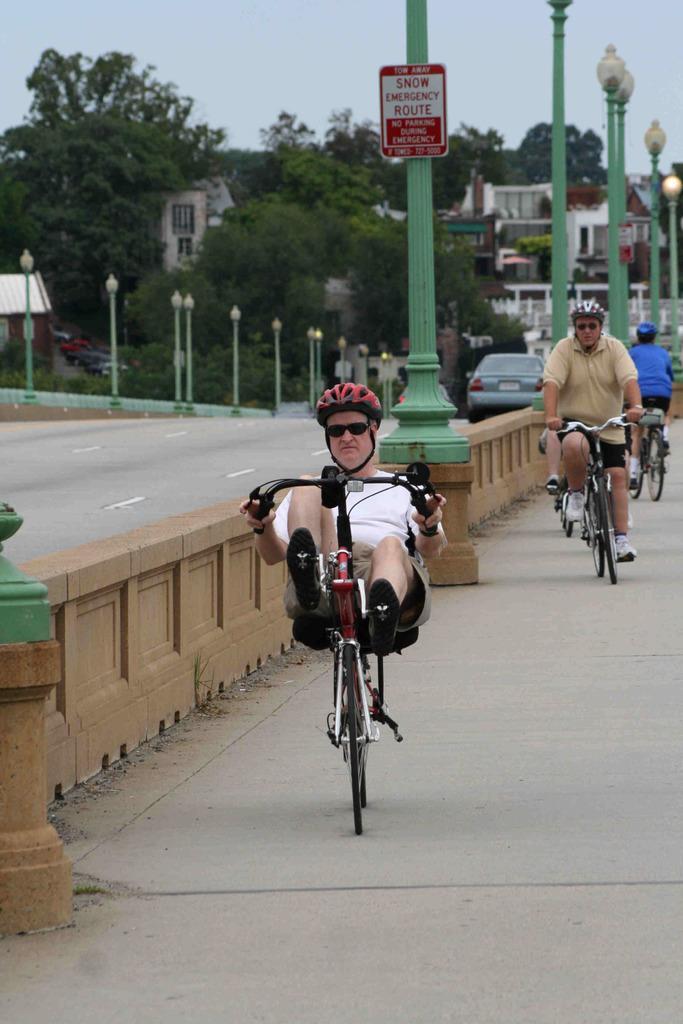Please provide a concise description of this image. In this image i can see few persons riding a bicycles, all of them are wearing helmets. In the background i can see few trees, few building, few poles, the sky and few vehicles. 